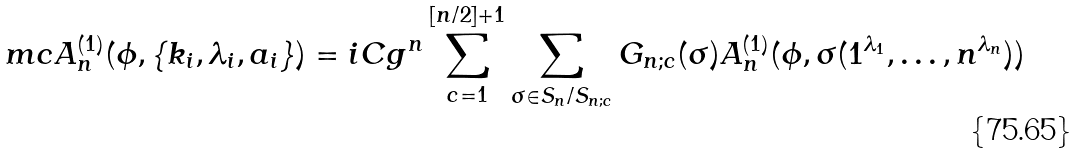<formula> <loc_0><loc_0><loc_500><loc_500>\ m c A ^ { ( 1 ) } _ { n } ( \phi , \{ k _ { i } , \lambda _ { i } , a _ { i } \} ) & = i C g ^ { n } \sum _ { c = 1 } ^ { [ n / 2 ] + 1 } \sum _ { \sigma \in S _ { n } / S _ { n ; c } } G _ { n ; c } ( \sigma ) A ^ { ( 1 ) } _ { n } ( \phi , \sigma ( 1 ^ { \lambda _ { 1 } } , \dots , n ^ { \lambda _ { n } } ) )</formula> 